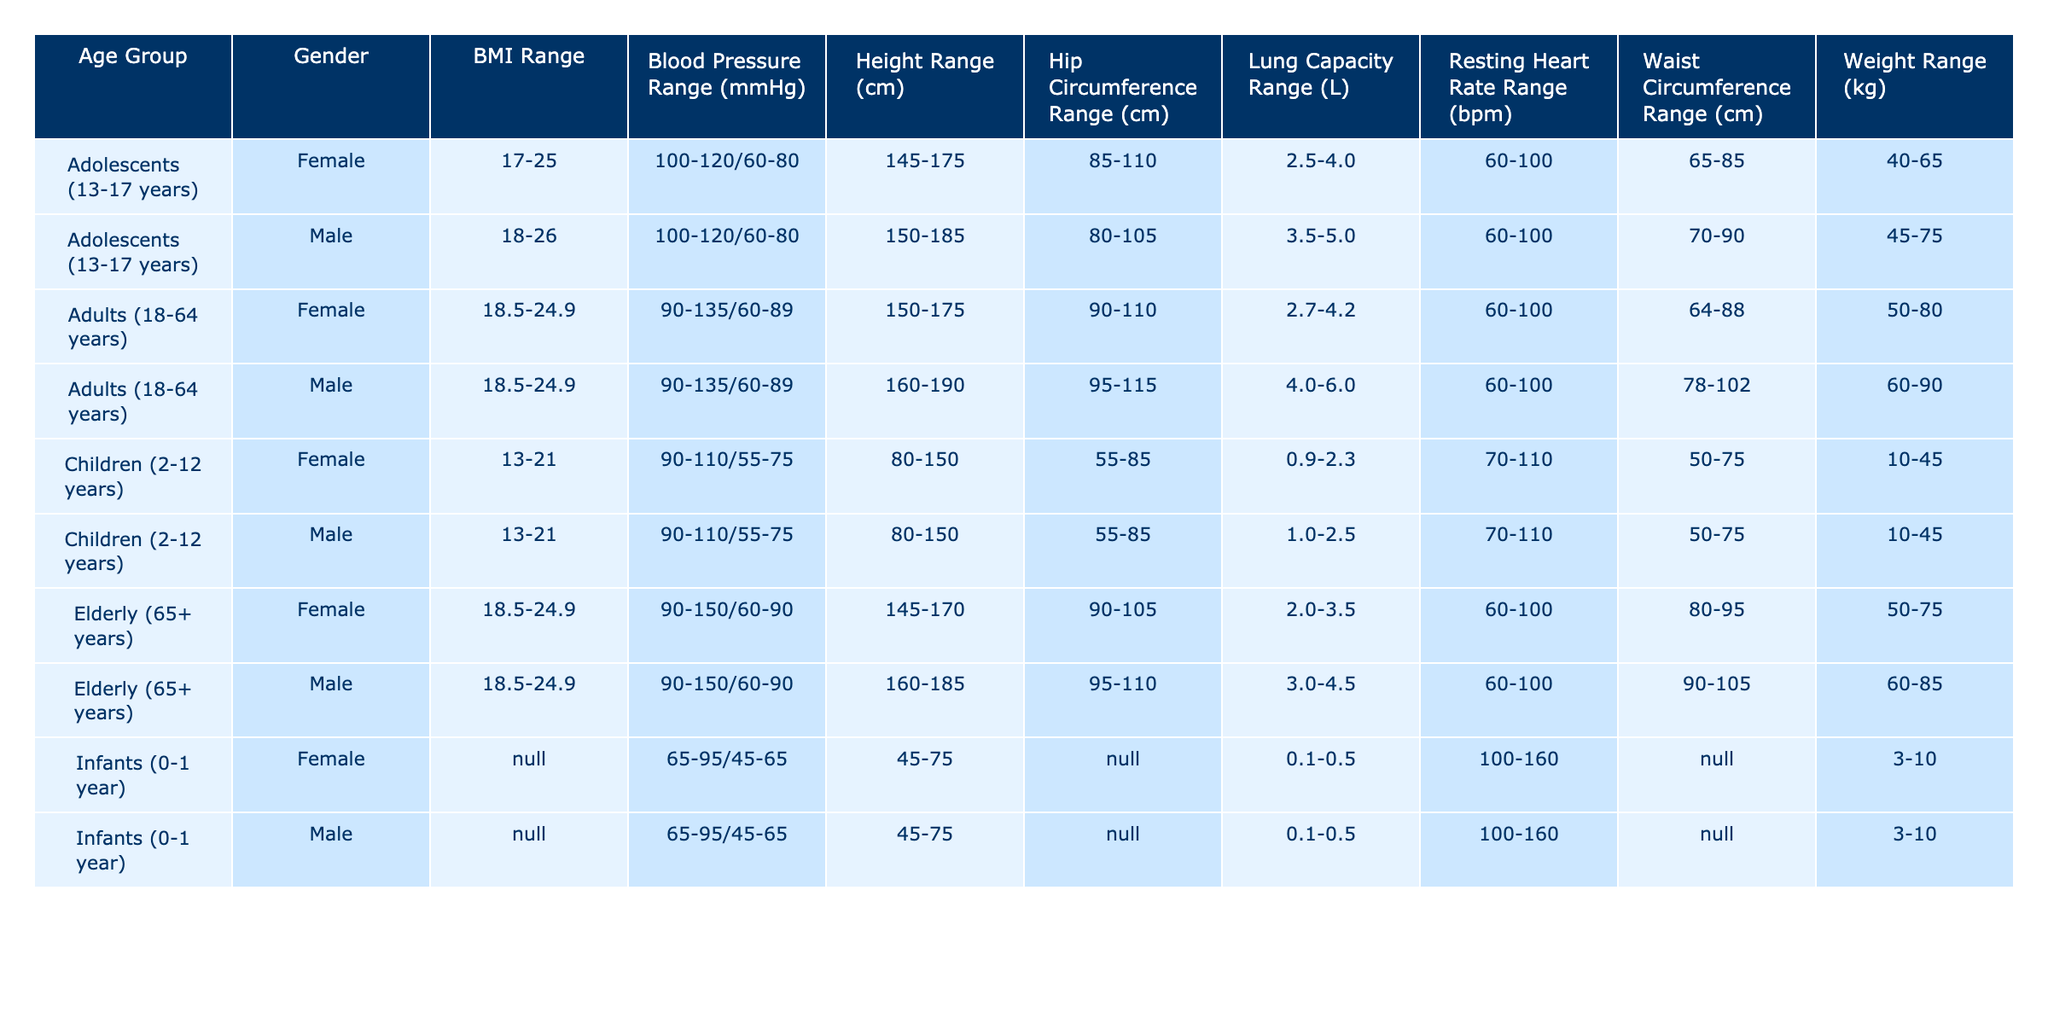What is the waist circumference range for adult females? According to the table, the waist circumference range for adult females (aged 18-64 years) is 64-88 cm.
Answer: 64-88 cm What is the weight range for children aged 2-12 years? The table shows that the weight range for children aged 2-12 years, regardless of gender, is 10-45 kg.
Answer: 10-45 kg Is the BMI range for infants provided in the table? The table indicates that the BMI range for infants (0-1 year) is marked as N/A, meaning no applicable data is provided.
Answer: No Which age group has the highest resting heart rate range? Upon examining the resting heart rate ranges for each age group, infants have the highest range of 100-160 bpm.
Answer: Infants (0-1 year) What is the difference in lung capacity range between adolescents and elderly? The lung capacity range for adolescents (13-17 years) is 3.5-5.0 L, while for elderly (65+ years) it is 2.0-4.5 L. The difference between the maximum values is 5.0 - 4.5 = 0.5 L and the minimum values are 3.5 - 2.0 = 1.5 L.
Answer: Maximum difference: 0.5 L, Minimum difference: 1.5 L Do adult males have a higher blood pressure range than adolescents? Adult males (aged 18-64 years) have a blood pressure range of 90-135/60-89 mmHg, while adolescent males (aged 13-17 years) have a range of 100-120/60-80 mmHg. The ranges show adult males having a broader upper limit.
Answer: Yes What is the average height of elderly females compared to male adolescents? The height range for elderly females is 145-170 cm and for male adolescents is 150-185 cm. The average height for elderly females is (145 + 170)/2 = 157.5 cm, and for male adolescents, it is (150 + 185)/2 = 167.5 cm. The average height of male adolescents is higher by 10 cm.
Answer: Male adolescents are taller by 10 cm Does the table provide a consistent BMI range across all groups for females? By analyzing the data, the BMI range for females in all age groups (Children, Adolescents, Adults, and Elderly) consistently falls between 17-25 and 18.5-24.9, demonstrating notable stability.
Answer: Yes Which gender has a lower average hip circumference range among the elderly? For elderly individuals, the hip circumference range for males is 95-110 cm, whereas for females, it is 90-105 cm. The average for males is 102.5 cm and for females is 97.5 cm. Thus, females have a lower average hip circumference.
Answer: Females have a lower average hip circumference 